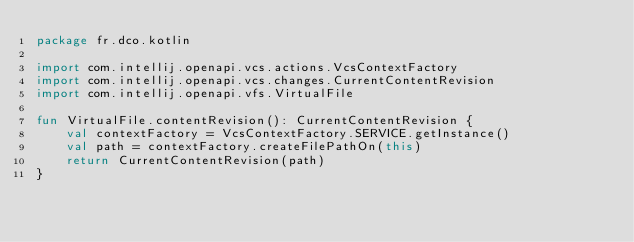Convert code to text. <code><loc_0><loc_0><loc_500><loc_500><_Kotlin_>package fr.dco.kotlin

import com.intellij.openapi.vcs.actions.VcsContextFactory
import com.intellij.openapi.vcs.changes.CurrentContentRevision
import com.intellij.openapi.vfs.VirtualFile

fun VirtualFile.contentRevision(): CurrentContentRevision {
    val contextFactory = VcsContextFactory.SERVICE.getInstance()
    val path = contextFactory.createFilePathOn(this)
    return CurrentContentRevision(path)
}</code> 